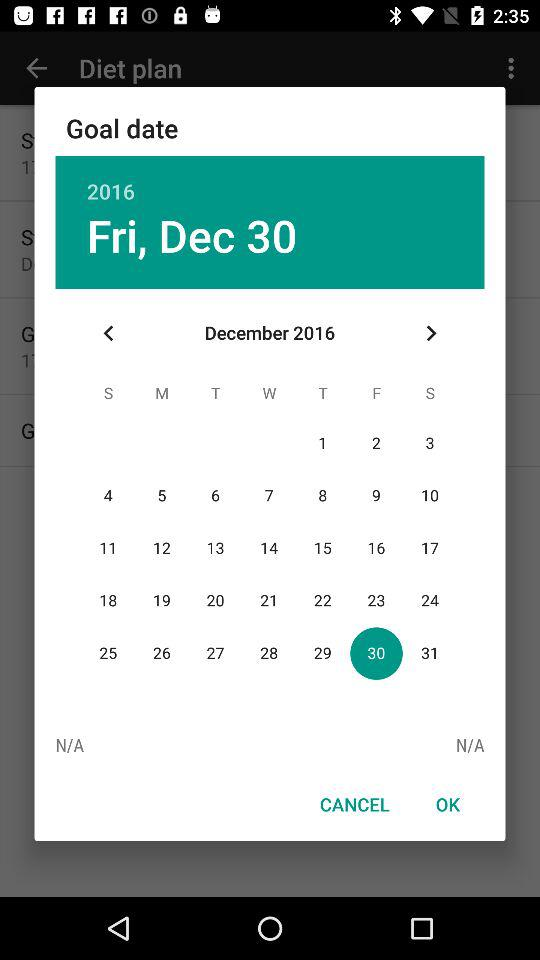What is the goal date? The goal date is Friday, December 30. 